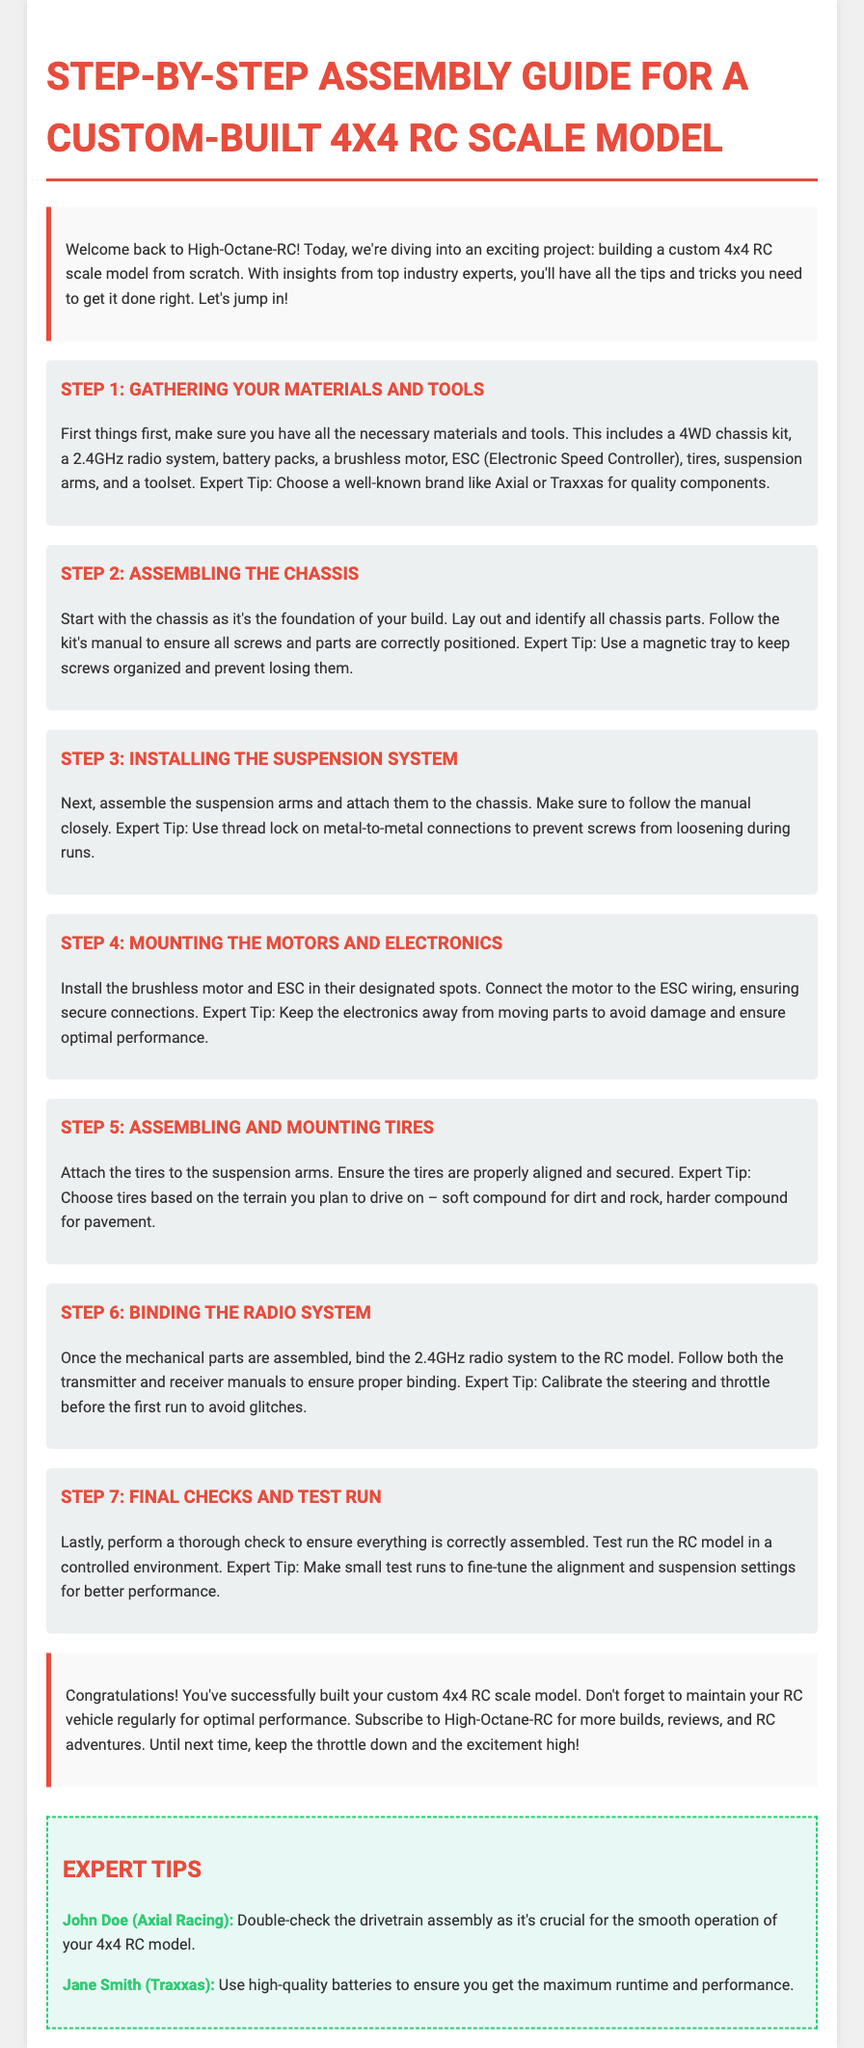what is the title of the document? The title of the document is stated in the header section of the HTML code.
Answer: Step-by-Step Assembly Guide for a Custom-Built 4x4 RC Scale Model how many steps are outlined in the assembly guide? The number of steps is provided in the step sections of the document.
Answer: 7 who gave expert tips on drivetrain assembly? The name of the expert who provided tips on drivetrain assembly is mentioned in the expert tips section.
Answer: John Doe what should you use on metal-to-metal connections? The document specifies what to use in a particular section about assembly.
Answer: Thread lock which component is essential for optimal performance? The document emphasizes the importance of a certain component in the expert tips section.
Answer: High-quality batteries what should be done before the first run? The document advises a specific action to take prior to the first operation of the RC model.
Answer: Calibrate the steering and throttle what is the color of the step titles? The document describes the color style for step titles in the CSS section.
Answer: Red 